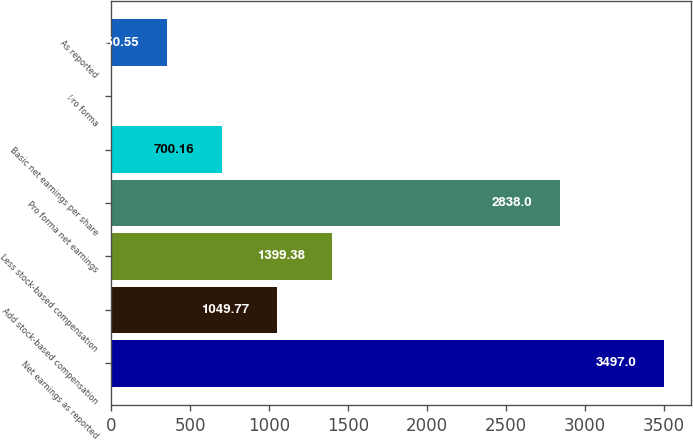Convert chart. <chart><loc_0><loc_0><loc_500><loc_500><bar_chart><fcel>Net earnings as reported<fcel>Add stock-based compensation<fcel>Less stock-based compensation<fcel>Pro forma net earnings<fcel>Basic net earnings per share<fcel>Pro forma<fcel>As reported<nl><fcel>3497<fcel>1049.77<fcel>1399.38<fcel>2838<fcel>700.16<fcel>0.94<fcel>350.55<nl></chart> 